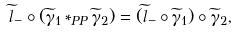Convert formula to latex. <formula><loc_0><loc_0><loc_500><loc_500>\widetilde { l } _ { - } \circ ( \widetilde { \gamma } _ { 1 } * _ { P P } \widetilde { \gamma } _ { 2 } ) = ( \widetilde { l } _ { - } \circ \widetilde { \gamma } _ { 1 } ) \circ \widetilde { \gamma } _ { 2 } ,</formula> 